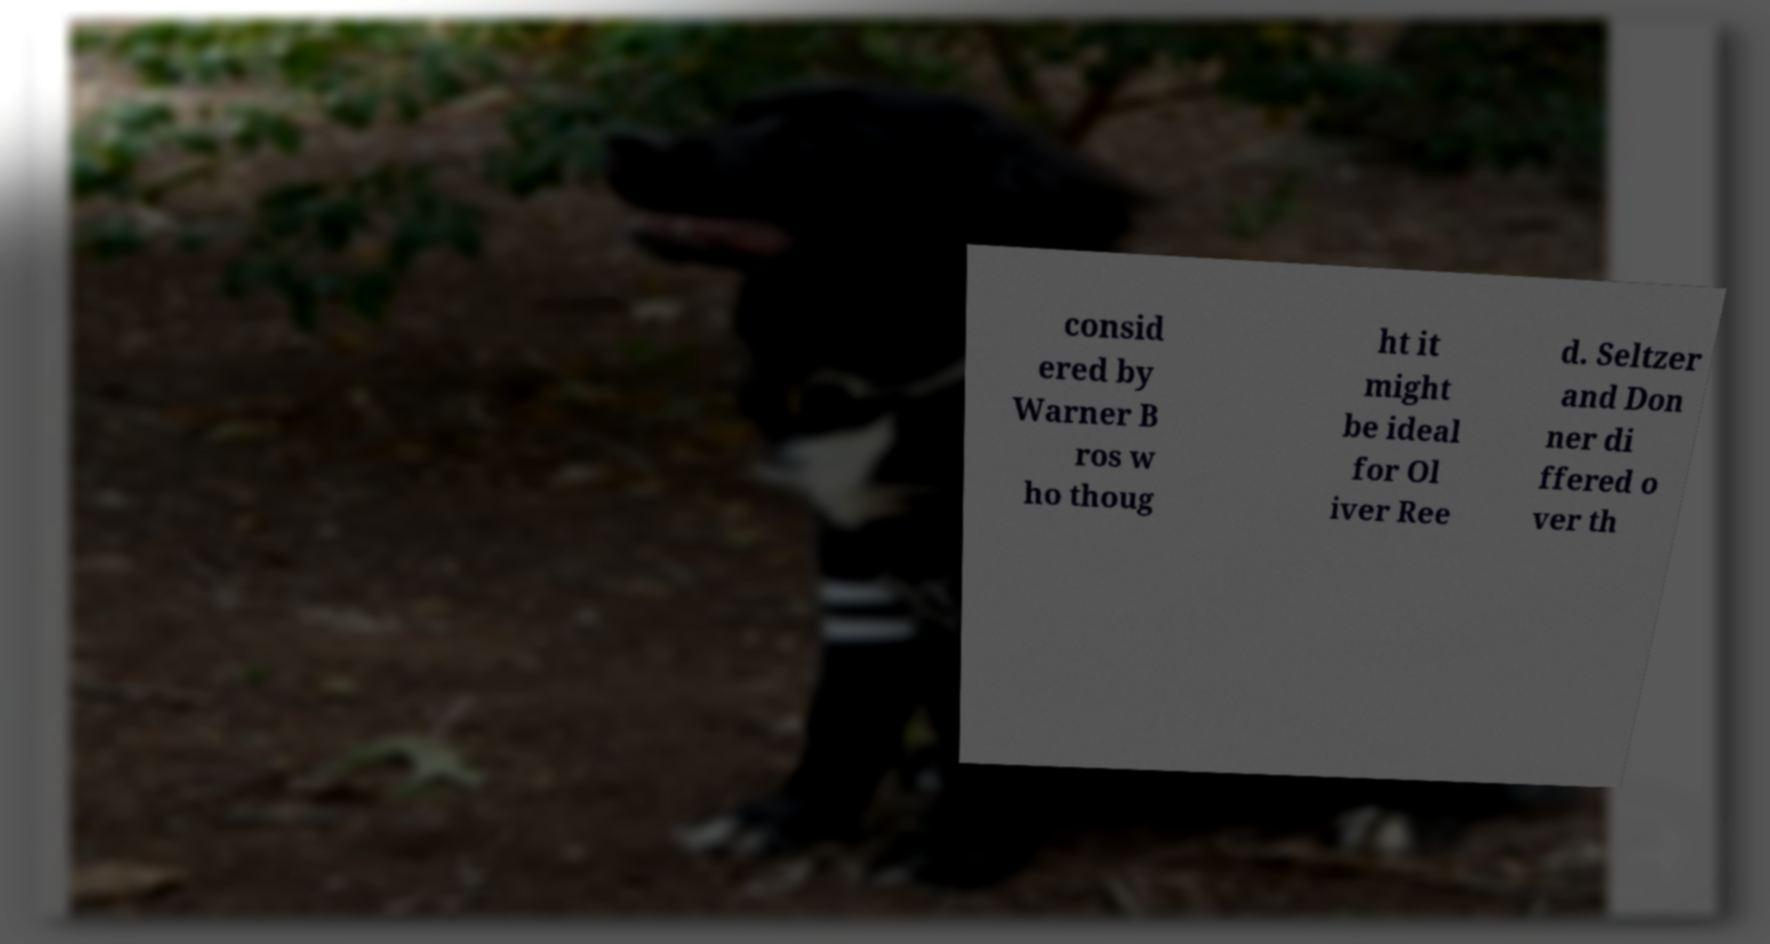Can you accurately transcribe the text from the provided image for me? consid ered by Warner B ros w ho thoug ht it might be ideal for Ol iver Ree d. Seltzer and Don ner di ffered o ver th 